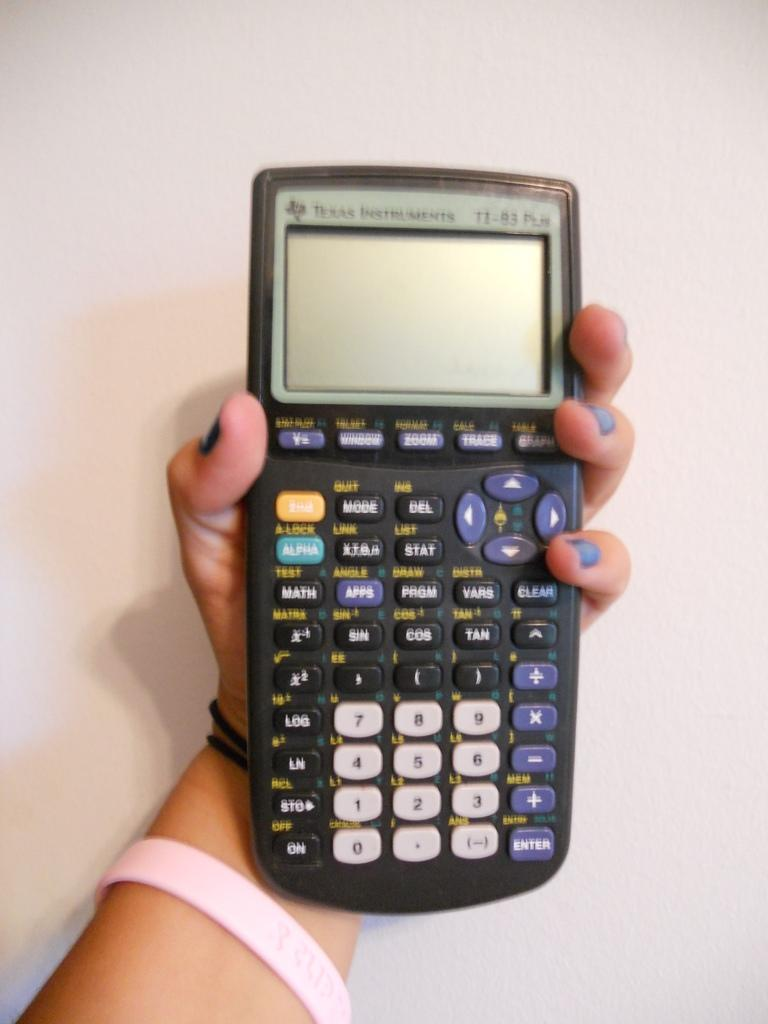<image>
Summarize the visual content of the image. A person is holding a Texas Instrument and has a pink bracelet on. 